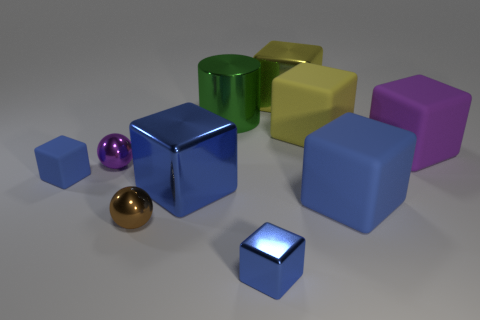There is a blue matte object that is on the left side of the yellow metallic thing; what is its shape?
Keep it short and to the point. Cube. There is a purple thing that is the same size as the green object; what is it made of?
Offer a terse response. Rubber. What number of objects are either small blue blocks that are behind the brown shiny sphere or balls that are behind the large blue matte cube?
Give a very brief answer. 2. What size is the purple ball that is made of the same material as the large green cylinder?
Ensure brevity in your answer.  Small. Are there an equal number of yellow blocks and purple matte things?
Ensure brevity in your answer.  No. What number of matte objects are cylinders or blocks?
Give a very brief answer. 4. How big is the yellow rubber object?
Offer a terse response. Large. Do the brown metallic sphere and the cylinder have the same size?
Your response must be concise. No. There is a tiny cube that is in front of the brown object; what material is it?
Offer a terse response. Metal. There is a brown object that is the same shape as the tiny purple shiny thing; what is it made of?
Ensure brevity in your answer.  Metal. 